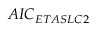Convert formula to latex. <formula><loc_0><loc_0><loc_500><loc_500>A I C _ { E T A S L C 2 }</formula> 